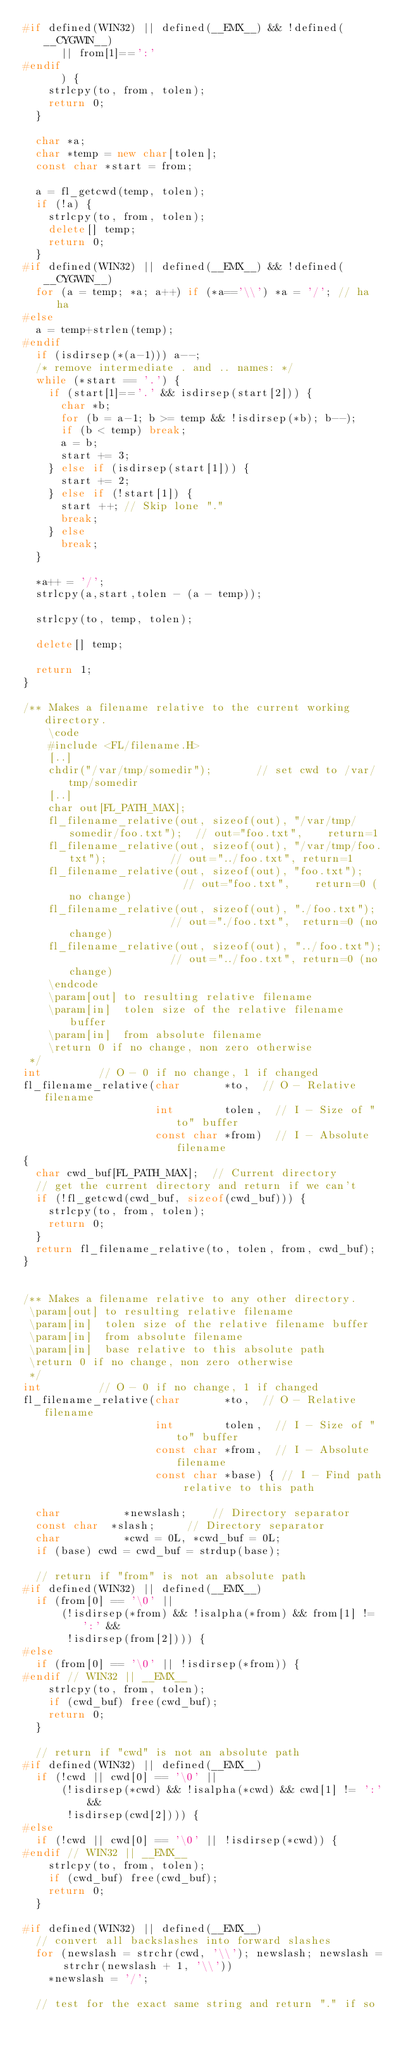<code> <loc_0><loc_0><loc_500><loc_500><_C++_>#if defined(WIN32) || defined(__EMX__) && !defined(__CYGWIN__)
      || from[1]==':'
#endif
      ) {
    strlcpy(to, from, tolen);
    return 0;
  }

  char *a;
  char *temp = new char[tolen];
  const char *start = from;

  a = fl_getcwd(temp, tolen);
  if (!a) {
    strlcpy(to, from, tolen);
    delete[] temp;
    return 0;
  }
#if defined(WIN32) || defined(__EMX__) && !defined(__CYGWIN__)
  for (a = temp; *a; a++) if (*a=='\\') *a = '/'; // ha ha
#else
  a = temp+strlen(temp);
#endif
  if (isdirsep(*(a-1))) a--;
  /* remove intermediate . and .. names: */
  while (*start == '.') {
    if (start[1]=='.' && isdirsep(start[2])) {
      char *b;
      for (b = a-1; b >= temp && !isdirsep(*b); b--);
      if (b < temp) break;
      a = b;
      start += 3;
    } else if (isdirsep(start[1])) {
      start += 2;
    } else if (!start[1]) {
      start ++; // Skip lone "."
      break;
    } else
      break;
  }

  *a++ = '/';
  strlcpy(a,start,tolen - (a - temp));

  strlcpy(to, temp, tolen);

  delete[] temp;

  return 1;
}

/** Makes a filename relative to the current working directory.
    \code
    #include <FL/filename.H>
    [..]
    chdir("/var/tmp/somedir");       // set cwd to /var/tmp/somedir
    [..]
    char out[FL_PATH_MAX];
    fl_filename_relative(out, sizeof(out), "/var/tmp/somedir/foo.txt");  // out="foo.txt",    return=1
    fl_filename_relative(out, sizeof(out), "/var/tmp/foo.txt");          // out="../foo.txt", return=1
    fl_filename_relative(out, sizeof(out), "foo.txt");                   // out="foo.txt",    return=0 (no change)
    fl_filename_relative(out, sizeof(out), "./foo.txt");                 // out="./foo.txt",  return=0 (no change)
    fl_filename_relative(out, sizeof(out), "../foo.txt");                // out="../foo.txt", return=0 (no change)
    \endcode
    \param[out] to resulting relative filename
    \param[in]  tolen size of the relative filename buffer 
    \param[in]  from absolute filename
    \return 0 if no change, non zero otherwise
 */
int					// O - 0 if no change, 1 if changed
fl_filename_relative(char       *to,	// O - Relative filename
                     int        tolen,	// I - Size of "to" buffer
                     const char *from)  // I - Absolute filename
{
  char cwd_buf[FL_PATH_MAX];	// Current directory
  // get the current directory and return if we can't
  if (!fl_getcwd(cwd_buf, sizeof(cwd_buf))) {
    strlcpy(to, from, tolen);
    return 0;
  }
  return fl_filename_relative(to, tolen, from, cwd_buf);
}


/** Makes a filename relative to any other directory.
 \param[out] to resulting relative filename
 \param[in]  tolen size of the relative filename buffer 
 \param[in]  from absolute filename
 \param[in]  base relative to this absolute path
 \return 0 if no change, non zero otherwise
 */
int					// O - 0 if no change, 1 if changed
fl_filename_relative(char       *to,	// O - Relative filename
                     int        tolen,	// I - Size of "to" buffer
                     const char *from,  // I - Absolute filename
                     const char *base) { // I - Find path relative to this path
  
  char          *newslash;		// Directory separator
  const char	*slash;			// Directory separator
  char          *cwd = 0L, *cwd_buf = 0L;
  if (base) cwd = cwd_buf = strdup(base);
  
  // return if "from" is not an absolute path
#if defined(WIN32) || defined(__EMX__)
  if (from[0] == '\0' ||
      (!isdirsep(*from) && !isalpha(*from) && from[1] != ':' &&
       !isdirsep(from[2]))) {
#else
  if (from[0] == '\0' || !isdirsep(*from)) {
#endif // WIN32 || __EMX__
    strlcpy(to, from, tolen);
    if (cwd_buf) free(cwd_buf);
    return 0;
  }
        
  // return if "cwd" is not an absolute path
#if defined(WIN32) || defined(__EMX__)
  if (!cwd || cwd[0] == '\0' ||
      (!isdirsep(*cwd) && !isalpha(*cwd) && cwd[1] != ':' &&
       !isdirsep(cwd[2]))) {
#else
  if (!cwd || cwd[0] == '\0' || !isdirsep(*cwd)) {
#endif // WIN32 || __EMX__
    strlcpy(to, from, tolen);
    if (cwd_buf) free(cwd_buf);
    return 0;
  }
              
#if defined(WIN32) || defined(__EMX__)
  // convert all backslashes into forward slashes
  for (newslash = strchr(cwd, '\\'); newslash; newslash = strchr(newslash + 1, '\\'))
    *newslash = '/';

  // test for the exact same string and return "." if so</code> 